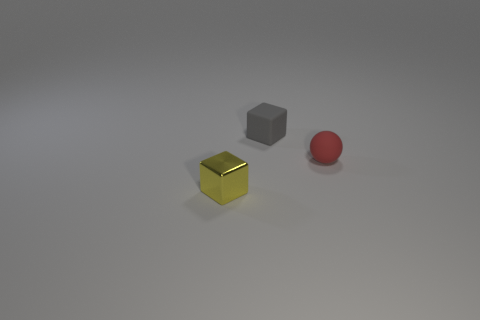Add 1 red balls. How many objects exist? 4 Subtract all balls. How many objects are left? 2 Add 1 tiny gray matte blocks. How many tiny gray matte blocks are left? 2 Add 3 small yellow shiny cylinders. How many small yellow shiny cylinders exist? 3 Subtract 1 gray blocks. How many objects are left? 2 Subtract all gray blocks. Subtract all cyan cylinders. How many blocks are left? 1 Subtract all purple cylinders. How many green balls are left? 0 Subtract all tiny matte objects. Subtract all big yellow metallic spheres. How many objects are left? 1 